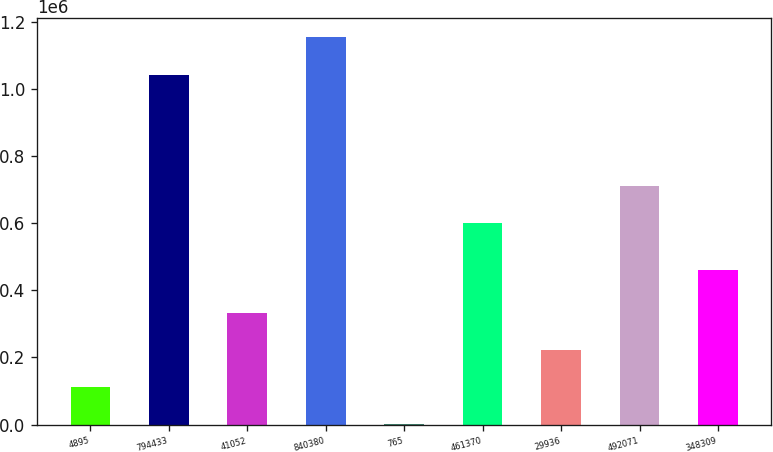Convert chart to OTSL. <chart><loc_0><loc_0><loc_500><loc_500><bar_chart><fcel>4895<fcel>794433<fcel>41052<fcel>840380<fcel>765<fcel>461370<fcel>29936<fcel>492071<fcel>348309<nl><fcel>111526<fcel>1.0428e+06<fcel>332859<fcel>1.15347e+06<fcel>860<fcel>601620<fcel>222193<fcel>712286<fcel>461394<nl></chart> 